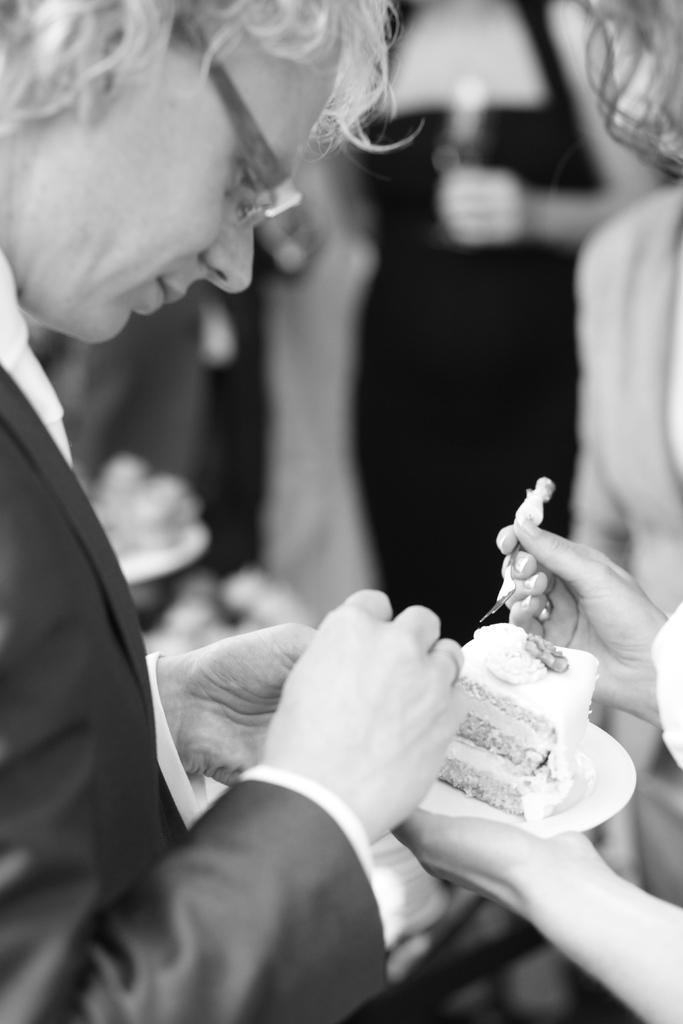How would you summarize this image in a sentence or two? It is the black and white image in which there is a person who is taking the cake with the spoon. On the right side there is a person who is holding the cake which is on the plate. In the background there is a woman who is holding the glass. 